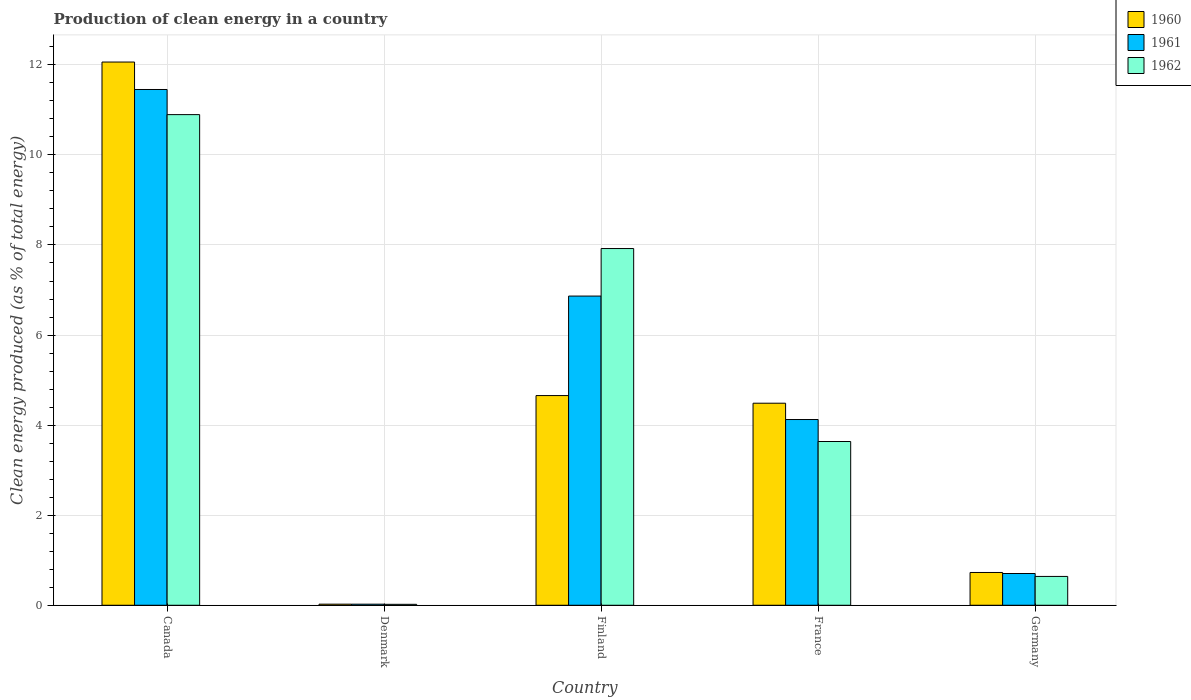Are the number of bars on each tick of the X-axis equal?
Give a very brief answer. Yes. How many bars are there on the 2nd tick from the right?
Make the answer very short. 3. What is the percentage of clean energy produced in 1961 in Canada?
Make the answer very short. 11.45. Across all countries, what is the maximum percentage of clean energy produced in 1960?
Offer a terse response. 12.06. Across all countries, what is the minimum percentage of clean energy produced in 1960?
Ensure brevity in your answer.  0.02. In which country was the percentage of clean energy produced in 1961 minimum?
Provide a short and direct response. Denmark. What is the total percentage of clean energy produced in 1960 in the graph?
Keep it short and to the point. 21.96. What is the difference between the percentage of clean energy produced in 1960 in Canada and that in Denmark?
Your answer should be very brief. 12.04. What is the difference between the percentage of clean energy produced in 1961 in Canada and the percentage of clean energy produced in 1962 in France?
Offer a terse response. 7.82. What is the average percentage of clean energy produced in 1962 per country?
Offer a very short reply. 4.62. What is the difference between the percentage of clean energy produced of/in 1962 and percentage of clean energy produced of/in 1961 in France?
Make the answer very short. -0.49. What is the ratio of the percentage of clean energy produced in 1962 in Canada to that in Germany?
Offer a very short reply. 17.02. Is the difference between the percentage of clean energy produced in 1962 in Canada and France greater than the difference between the percentage of clean energy produced in 1961 in Canada and France?
Your response must be concise. No. What is the difference between the highest and the second highest percentage of clean energy produced in 1962?
Provide a short and direct response. 7.26. What is the difference between the highest and the lowest percentage of clean energy produced in 1962?
Offer a very short reply. 10.87. In how many countries, is the percentage of clean energy produced in 1962 greater than the average percentage of clean energy produced in 1962 taken over all countries?
Ensure brevity in your answer.  2. What does the 2nd bar from the right in Finland represents?
Keep it short and to the point. 1961. Is it the case that in every country, the sum of the percentage of clean energy produced in 1962 and percentage of clean energy produced in 1961 is greater than the percentage of clean energy produced in 1960?
Keep it short and to the point. Yes. How many bars are there?
Make the answer very short. 15. Are all the bars in the graph horizontal?
Offer a terse response. No. How many countries are there in the graph?
Your response must be concise. 5. What is the difference between two consecutive major ticks on the Y-axis?
Give a very brief answer. 2. Does the graph contain any zero values?
Your response must be concise. No. Where does the legend appear in the graph?
Your answer should be very brief. Top right. How many legend labels are there?
Make the answer very short. 3. What is the title of the graph?
Make the answer very short. Production of clean energy in a country. Does "1969" appear as one of the legend labels in the graph?
Offer a terse response. No. What is the label or title of the Y-axis?
Provide a succinct answer. Clean energy produced (as % of total energy). What is the Clean energy produced (as % of total energy) in 1960 in Canada?
Give a very brief answer. 12.06. What is the Clean energy produced (as % of total energy) of 1961 in Canada?
Keep it short and to the point. 11.45. What is the Clean energy produced (as % of total energy) of 1962 in Canada?
Your answer should be compact. 10.89. What is the Clean energy produced (as % of total energy) of 1960 in Denmark?
Provide a succinct answer. 0.02. What is the Clean energy produced (as % of total energy) of 1961 in Denmark?
Provide a succinct answer. 0.02. What is the Clean energy produced (as % of total energy) in 1962 in Denmark?
Ensure brevity in your answer.  0.02. What is the Clean energy produced (as % of total energy) of 1960 in Finland?
Your response must be concise. 4.66. What is the Clean energy produced (as % of total energy) of 1961 in Finland?
Offer a terse response. 6.87. What is the Clean energy produced (as % of total energy) in 1962 in Finland?
Keep it short and to the point. 7.92. What is the Clean energy produced (as % of total energy) of 1960 in France?
Your answer should be compact. 4.49. What is the Clean energy produced (as % of total energy) of 1961 in France?
Your answer should be compact. 4.12. What is the Clean energy produced (as % of total energy) of 1962 in France?
Give a very brief answer. 3.64. What is the Clean energy produced (as % of total energy) of 1960 in Germany?
Provide a short and direct response. 0.73. What is the Clean energy produced (as % of total energy) in 1961 in Germany?
Make the answer very short. 0.7. What is the Clean energy produced (as % of total energy) in 1962 in Germany?
Your response must be concise. 0.64. Across all countries, what is the maximum Clean energy produced (as % of total energy) in 1960?
Keep it short and to the point. 12.06. Across all countries, what is the maximum Clean energy produced (as % of total energy) of 1961?
Give a very brief answer. 11.45. Across all countries, what is the maximum Clean energy produced (as % of total energy) in 1962?
Offer a very short reply. 10.89. Across all countries, what is the minimum Clean energy produced (as % of total energy) in 1960?
Your answer should be very brief. 0.02. Across all countries, what is the minimum Clean energy produced (as % of total energy) in 1961?
Keep it short and to the point. 0.02. Across all countries, what is the minimum Clean energy produced (as % of total energy) in 1962?
Offer a very short reply. 0.02. What is the total Clean energy produced (as % of total energy) of 1960 in the graph?
Offer a terse response. 21.96. What is the total Clean energy produced (as % of total energy) in 1961 in the graph?
Your answer should be very brief. 23.17. What is the total Clean energy produced (as % of total energy) of 1962 in the graph?
Offer a very short reply. 23.11. What is the difference between the Clean energy produced (as % of total energy) in 1960 in Canada and that in Denmark?
Your answer should be compact. 12.04. What is the difference between the Clean energy produced (as % of total energy) of 1961 in Canada and that in Denmark?
Your response must be concise. 11.43. What is the difference between the Clean energy produced (as % of total energy) of 1962 in Canada and that in Denmark?
Ensure brevity in your answer.  10.87. What is the difference between the Clean energy produced (as % of total energy) of 1960 in Canada and that in Finland?
Provide a short and direct response. 7.41. What is the difference between the Clean energy produced (as % of total energy) in 1961 in Canada and that in Finland?
Ensure brevity in your answer.  4.59. What is the difference between the Clean energy produced (as % of total energy) of 1962 in Canada and that in Finland?
Provide a succinct answer. 2.97. What is the difference between the Clean energy produced (as % of total energy) in 1960 in Canada and that in France?
Ensure brevity in your answer.  7.58. What is the difference between the Clean energy produced (as % of total energy) of 1961 in Canada and that in France?
Ensure brevity in your answer.  7.33. What is the difference between the Clean energy produced (as % of total energy) in 1962 in Canada and that in France?
Provide a short and direct response. 7.26. What is the difference between the Clean energy produced (as % of total energy) in 1960 in Canada and that in Germany?
Offer a very short reply. 11.33. What is the difference between the Clean energy produced (as % of total energy) in 1961 in Canada and that in Germany?
Keep it short and to the point. 10.75. What is the difference between the Clean energy produced (as % of total energy) of 1962 in Canada and that in Germany?
Make the answer very short. 10.25. What is the difference between the Clean energy produced (as % of total energy) in 1960 in Denmark and that in Finland?
Your response must be concise. -4.63. What is the difference between the Clean energy produced (as % of total energy) in 1961 in Denmark and that in Finland?
Give a very brief answer. -6.84. What is the difference between the Clean energy produced (as % of total energy) of 1962 in Denmark and that in Finland?
Your response must be concise. -7.9. What is the difference between the Clean energy produced (as % of total energy) in 1960 in Denmark and that in France?
Provide a succinct answer. -4.46. What is the difference between the Clean energy produced (as % of total energy) of 1961 in Denmark and that in France?
Provide a short and direct response. -4.1. What is the difference between the Clean energy produced (as % of total energy) in 1962 in Denmark and that in France?
Offer a terse response. -3.62. What is the difference between the Clean energy produced (as % of total energy) in 1960 in Denmark and that in Germany?
Offer a very short reply. -0.7. What is the difference between the Clean energy produced (as % of total energy) in 1961 in Denmark and that in Germany?
Your answer should be compact. -0.68. What is the difference between the Clean energy produced (as % of total energy) in 1962 in Denmark and that in Germany?
Offer a very short reply. -0.62. What is the difference between the Clean energy produced (as % of total energy) in 1960 in Finland and that in France?
Your answer should be compact. 0.17. What is the difference between the Clean energy produced (as % of total energy) of 1961 in Finland and that in France?
Make the answer very short. 2.74. What is the difference between the Clean energy produced (as % of total energy) of 1962 in Finland and that in France?
Ensure brevity in your answer.  4.28. What is the difference between the Clean energy produced (as % of total energy) of 1960 in Finland and that in Germany?
Offer a very short reply. 3.93. What is the difference between the Clean energy produced (as % of total energy) in 1961 in Finland and that in Germany?
Offer a terse response. 6.16. What is the difference between the Clean energy produced (as % of total energy) of 1962 in Finland and that in Germany?
Keep it short and to the point. 7.28. What is the difference between the Clean energy produced (as % of total energy) in 1960 in France and that in Germany?
Provide a short and direct response. 3.76. What is the difference between the Clean energy produced (as % of total energy) of 1961 in France and that in Germany?
Ensure brevity in your answer.  3.42. What is the difference between the Clean energy produced (as % of total energy) of 1962 in France and that in Germany?
Your response must be concise. 3. What is the difference between the Clean energy produced (as % of total energy) in 1960 in Canada and the Clean energy produced (as % of total energy) in 1961 in Denmark?
Your response must be concise. 12.04. What is the difference between the Clean energy produced (as % of total energy) of 1960 in Canada and the Clean energy produced (as % of total energy) of 1962 in Denmark?
Keep it short and to the point. 12.04. What is the difference between the Clean energy produced (as % of total energy) of 1961 in Canada and the Clean energy produced (as % of total energy) of 1962 in Denmark?
Give a very brief answer. 11.43. What is the difference between the Clean energy produced (as % of total energy) of 1960 in Canada and the Clean energy produced (as % of total energy) of 1961 in Finland?
Ensure brevity in your answer.  5.2. What is the difference between the Clean energy produced (as % of total energy) in 1960 in Canada and the Clean energy produced (as % of total energy) in 1962 in Finland?
Give a very brief answer. 4.14. What is the difference between the Clean energy produced (as % of total energy) of 1961 in Canada and the Clean energy produced (as % of total energy) of 1962 in Finland?
Provide a succinct answer. 3.53. What is the difference between the Clean energy produced (as % of total energy) of 1960 in Canada and the Clean energy produced (as % of total energy) of 1961 in France?
Give a very brief answer. 7.94. What is the difference between the Clean energy produced (as % of total energy) in 1960 in Canada and the Clean energy produced (as % of total energy) in 1962 in France?
Your answer should be compact. 8.43. What is the difference between the Clean energy produced (as % of total energy) of 1961 in Canada and the Clean energy produced (as % of total energy) of 1962 in France?
Offer a terse response. 7.82. What is the difference between the Clean energy produced (as % of total energy) of 1960 in Canada and the Clean energy produced (as % of total energy) of 1961 in Germany?
Offer a terse response. 11.36. What is the difference between the Clean energy produced (as % of total energy) of 1960 in Canada and the Clean energy produced (as % of total energy) of 1962 in Germany?
Ensure brevity in your answer.  11.42. What is the difference between the Clean energy produced (as % of total energy) in 1961 in Canada and the Clean energy produced (as % of total energy) in 1962 in Germany?
Provide a succinct answer. 10.81. What is the difference between the Clean energy produced (as % of total energy) of 1960 in Denmark and the Clean energy produced (as % of total energy) of 1961 in Finland?
Ensure brevity in your answer.  -6.84. What is the difference between the Clean energy produced (as % of total energy) in 1960 in Denmark and the Clean energy produced (as % of total energy) in 1962 in Finland?
Your answer should be very brief. -7.9. What is the difference between the Clean energy produced (as % of total energy) in 1961 in Denmark and the Clean energy produced (as % of total energy) in 1962 in Finland?
Keep it short and to the point. -7.9. What is the difference between the Clean energy produced (as % of total energy) of 1960 in Denmark and the Clean energy produced (as % of total energy) of 1961 in France?
Give a very brief answer. -4.1. What is the difference between the Clean energy produced (as % of total energy) of 1960 in Denmark and the Clean energy produced (as % of total energy) of 1962 in France?
Your answer should be compact. -3.61. What is the difference between the Clean energy produced (as % of total energy) in 1961 in Denmark and the Clean energy produced (as % of total energy) in 1962 in France?
Ensure brevity in your answer.  -3.61. What is the difference between the Clean energy produced (as % of total energy) of 1960 in Denmark and the Clean energy produced (as % of total energy) of 1961 in Germany?
Offer a very short reply. -0.68. What is the difference between the Clean energy produced (as % of total energy) in 1960 in Denmark and the Clean energy produced (as % of total energy) in 1962 in Germany?
Keep it short and to the point. -0.62. What is the difference between the Clean energy produced (as % of total energy) of 1961 in Denmark and the Clean energy produced (as % of total energy) of 1962 in Germany?
Make the answer very short. -0.62. What is the difference between the Clean energy produced (as % of total energy) in 1960 in Finland and the Clean energy produced (as % of total energy) in 1961 in France?
Keep it short and to the point. 0.53. What is the difference between the Clean energy produced (as % of total energy) of 1960 in Finland and the Clean energy produced (as % of total energy) of 1962 in France?
Make the answer very short. 1.02. What is the difference between the Clean energy produced (as % of total energy) of 1961 in Finland and the Clean energy produced (as % of total energy) of 1962 in France?
Offer a terse response. 3.23. What is the difference between the Clean energy produced (as % of total energy) of 1960 in Finland and the Clean energy produced (as % of total energy) of 1961 in Germany?
Offer a very short reply. 3.95. What is the difference between the Clean energy produced (as % of total energy) in 1960 in Finland and the Clean energy produced (as % of total energy) in 1962 in Germany?
Your answer should be compact. 4.02. What is the difference between the Clean energy produced (as % of total energy) in 1961 in Finland and the Clean energy produced (as % of total energy) in 1962 in Germany?
Provide a short and direct response. 6.23. What is the difference between the Clean energy produced (as % of total energy) of 1960 in France and the Clean energy produced (as % of total energy) of 1961 in Germany?
Make the answer very short. 3.78. What is the difference between the Clean energy produced (as % of total energy) in 1960 in France and the Clean energy produced (as % of total energy) in 1962 in Germany?
Your answer should be very brief. 3.85. What is the difference between the Clean energy produced (as % of total energy) in 1961 in France and the Clean energy produced (as % of total energy) in 1962 in Germany?
Give a very brief answer. 3.48. What is the average Clean energy produced (as % of total energy) of 1960 per country?
Provide a short and direct response. 4.39. What is the average Clean energy produced (as % of total energy) in 1961 per country?
Make the answer very short. 4.63. What is the average Clean energy produced (as % of total energy) in 1962 per country?
Your answer should be compact. 4.62. What is the difference between the Clean energy produced (as % of total energy) in 1960 and Clean energy produced (as % of total energy) in 1961 in Canada?
Ensure brevity in your answer.  0.61. What is the difference between the Clean energy produced (as % of total energy) of 1960 and Clean energy produced (as % of total energy) of 1962 in Canada?
Give a very brief answer. 1.17. What is the difference between the Clean energy produced (as % of total energy) of 1961 and Clean energy produced (as % of total energy) of 1962 in Canada?
Your response must be concise. 0.56. What is the difference between the Clean energy produced (as % of total energy) of 1960 and Clean energy produced (as % of total energy) of 1961 in Denmark?
Give a very brief answer. 0. What is the difference between the Clean energy produced (as % of total energy) of 1960 and Clean energy produced (as % of total energy) of 1962 in Denmark?
Keep it short and to the point. 0. What is the difference between the Clean energy produced (as % of total energy) in 1961 and Clean energy produced (as % of total energy) in 1962 in Denmark?
Give a very brief answer. 0. What is the difference between the Clean energy produced (as % of total energy) in 1960 and Clean energy produced (as % of total energy) in 1961 in Finland?
Your response must be concise. -2.21. What is the difference between the Clean energy produced (as % of total energy) in 1960 and Clean energy produced (as % of total energy) in 1962 in Finland?
Your response must be concise. -3.26. What is the difference between the Clean energy produced (as % of total energy) of 1961 and Clean energy produced (as % of total energy) of 1962 in Finland?
Offer a terse response. -1.06. What is the difference between the Clean energy produced (as % of total energy) of 1960 and Clean energy produced (as % of total energy) of 1961 in France?
Ensure brevity in your answer.  0.36. What is the difference between the Clean energy produced (as % of total energy) in 1960 and Clean energy produced (as % of total energy) in 1962 in France?
Keep it short and to the point. 0.85. What is the difference between the Clean energy produced (as % of total energy) in 1961 and Clean energy produced (as % of total energy) in 1962 in France?
Ensure brevity in your answer.  0.49. What is the difference between the Clean energy produced (as % of total energy) in 1960 and Clean energy produced (as % of total energy) in 1961 in Germany?
Make the answer very short. 0.02. What is the difference between the Clean energy produced (as % of total energy) in 1960 and Clean energy produced (as % of total energy) in 1962 in Germany?
Ensure brevity in your answer.  0.09. What is the difference between the Clean energy produced (as % of total energy) of 1961 and Clean energy produced (as % of total energy) of 1962 in Germany?
Keep it short and to the point. 0.06. What is the ratio of the Clean energy produced (as % of total energy) in 1960 in Canada to that in Denmark?
Your answer should be compact. 494.07. What is the ratio of the Clean energy produced (as % of total energy) of 1961 in Canada to that in Denmark?
Provide a short and direct response. 477.92. What is the ratio of the Clean energy produced (as % of total energy) of 1962 in Canada to that in Denmark?
Keep it short and to the point. 520.01. What is the ratio of the Clean energy produced (as % of total energy) in 1960 in Canada to that in Finland?
Keep it short and to the point. 2.59. What is the ratio of the Clean energy produced (as % of total energy) of 1961 in Canada to that in Finland?
Your response must be concise. 1.67. What is the ratio of the Clean energy produced (as % of total energy) of 1962 in Canada to that in Finland?
Provide a short and direct response. 1.38. What is the ratio of the Clean energy produced (as % of total energy) of 1960 in Canada to that in France?
Make the answer very short. 2.69. What is the ratio of the Clean energy produced (as % of total energy) of 1961 in Canada to that in France?
Make the answer very short. 2.78. What is the ratio of the Clean energy produced (as % of total energy) in 1962 in Canada to that in France?
Give a very brief answer. 3. What is the ratio of the Clean energy produced (as % of total energy) in 1960 in Canada to that in Germany?
Ensure brevity in your answer.  16.57. What is the ratio of the Clean energy produced (as % of total energy) of 1961 in Canada to that in Germany?
Provide a succinct answer. 16.25. What is the ratio of the Clean energy produced (as % of total energy) in 1962 in Canada to that in Germany?
Your answer should be very brief. 17.02. What is the ratio of the Clean energy produced (as % of total energy) of 1960 in Denmark to that in Finland?
Keep it short and to the point. 0.01. What is the ratio of the Clean energy produced (as % of total energy) in 1961 in Denmark to that in Finland?
Make the answer very short. 0. What is the ratio of the Clean energy produced (as % of total energy) in 1962 in Denmark to that in Finland?
Make the answer very short. 0. What is the ratio of the Clean energy produced (as % of total energy) of 1960 in Denmark to that in France?
Your response must be concise. 0.01. What is the ratio of the Clean energy produced (as % of total energy) in 1961 in Denmark to that in France?
Your answer should be compact. 0.01. What is the ratio of the Clean energy produced (as % of total energy) in 1962 in Denmark to that in France?
Keep it short and to the point. 0.01. What is the ratio of the Clean energy produced (as % of total energy) in 1960 in Denmark to that in Germany?
Your answer should be compact. 0.03. What is the ratio of the Clean energy produced (as % of total energy) of 1961 in Denmark to that in Germany?
Your answer should be compact. 0.03. What is the ratio of the Clean energy produced (as % of total energy) in 1962 in Denmark to that in Germany?
Keep it short and to the point. 0.03. What is the ratio of the Clean energy produced (as % of total energy) of 1960 in Finland to that in France?
Your answer should be compact. 1.04. What is the ratio of the Clean energy produced (as % of total energy) in 1961 in Finland to that in France?
Give a very brief answer. 1.66. What is the ratio of the Clean energy produced (as % of total energy) in 1962 in Finland to that in France?
Give a very brief answer. 2.18. What is the ratio of the Clean energy produced (as % of total energy) of 1960 in Finland to that in Germany?
Keep it short and to the point. 6.4. What is the ratio of the Clean energy produced (as % of total energy) in 1961 in Finland to that in Germany?
Keep it short and to the point. 9.74. What is the ratio of the Clean energy produced (as % of total energy) in 1962 in Finland to that in Germany?
Your answer should be very brief. 12.37. What is the ratio of the Clean energy produced (as % of total energy) in 1960 in France to that in Germany?
Offer a terse response. 6.16. What is the ratio of the Clean energy produced (as % of total energy) of 1961 in France to that in Germany?
Provide a short and direct response. 5.85. What is the ratio of the Clean energy produced (as % of total energy) of 1962 in France to that in Germany?
Keep it short and to the point. 5.68. What is the difference between the highest and the second highest Clean energy produced (as % of total energy) in 1960?
Ensure brevity in your answer.  7.41. What is the difference between the highest and the second highest Clean energy produced (as % of total energy) of 1961?
Make the answer very short. 4.59. What is the difference between the highest and the second highest Clean energy produced (as % of total energy) in 1962?
Offer a terse response. 2.97. What is the difference between the highest and the lowest Clean energy produced (as % of total energy) of 1960?
Offer a very short reply. 12.04. What is the difference between the highest and the lowest Clean energy produced (as % of total energy) in 1961?
Make the answer very short. 11.43. What is the difference between the highest and the lowest Clean energy produced (as % of total energy) in 1962?
Ensure brevity in your answer.  10.87. 